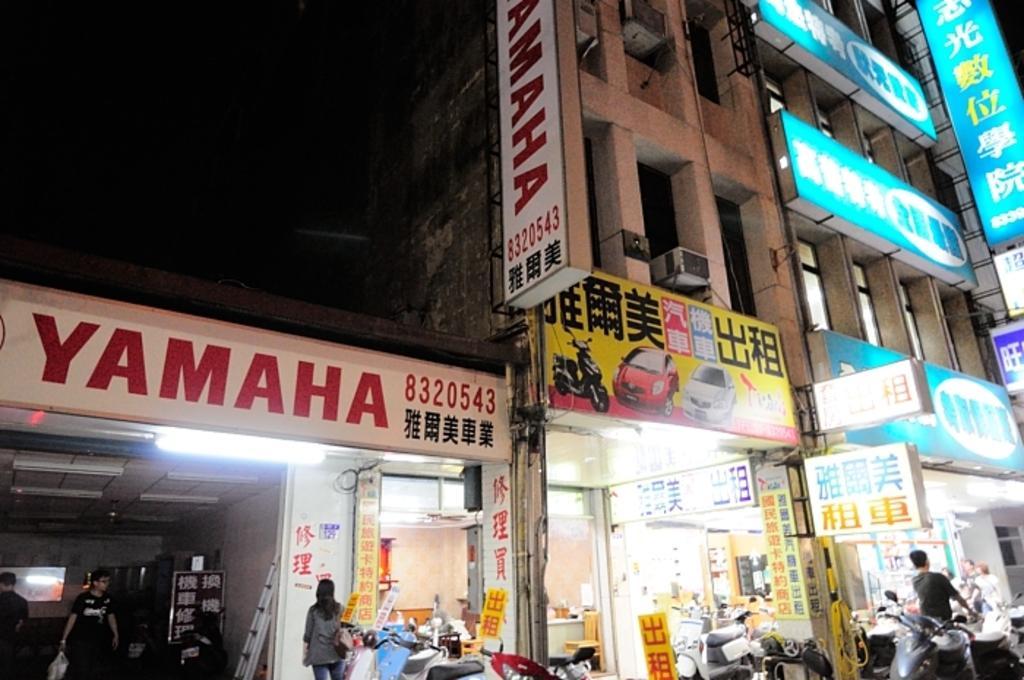In one or two sentences, can you explain what this image depicts? In this image, we can see few store, banners, hoardings, building, walls and rods. At the bottom of the image, we can see few people, some objects, vehicles. On the left side top of the image, we can see a dark view. 